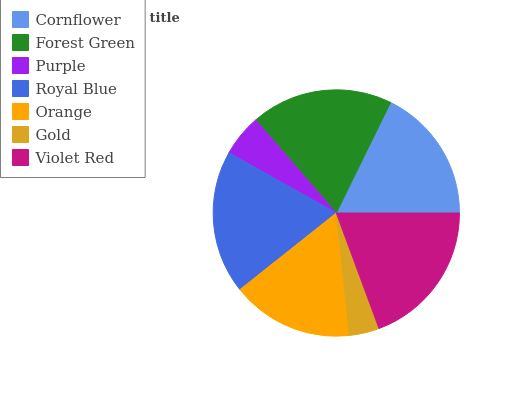Is Gold the minimum?
Answer yes or no. Yes. Is Violet Red the maximum?
Answer yes or no. Yes. Is Forest Green the minimum?
Answer yes or no. No. Is Forest Green the maximum?
Answer yes or no. No. Is Forest Green greater than Cornflower?
Answer yes or no. Yes. Is Cornflower less than Forest Green?
Answer yes or no. Yes. Is Cornflower greater than Forest Green?
Answer yes or no. No. Is Forest Green less than Cornflower?
Answer yes or no. No. Is Cornflower the high median?
Answer yes or no. Yes. Is Cornflower the low median?
Answer yes or no. Yes. Is Gold the high median?
Answer yes or no. No. Is Purple the low median?
Answer yes or no. No. 